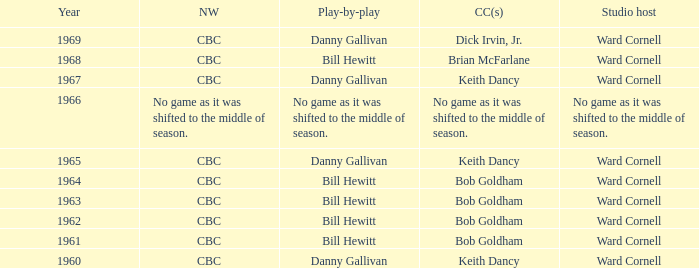Write the full table. {'header': ['Year', 'NW', 'Play-by-play', 'CC(s)', 'Studio host'], 'rows': [['1969', 'CBC', 'Danny Gallivan', 'Dick Irvin, Jr.', 'Ward Cornell'], ['1968', 'CBC', 'Bill Hewitt', 'Brian McFarlane', 'Ward Cornell'], ['1967', 'CBC', 'Danny Gallivan', 'Keith Dancy', 'Ward Cornell'], ['1966', 'No game as it was shifted to the middle of season.', 'No game as it was shifted to the middle of season.', 'No game as it was shifted to the middle of season.', 'No game as it was shifted to the middle of season.'], ['1965', 'CBC', 'Danny Gallivan', 'Keith Dancy', 'Ward Cornell'], ['1964', 'CBC', 'Bill Hewitt', 'Bob Goldham', 'Ward Cornell'], ['1963', 'CBC', 'Bill Hewitt', 'Bob Goldham', 'Ward Cornell'], ['1962', 'CBC', 'Bill Hewitt', 'Bob Goldham', 'Ward Cornell'], ['1961', 'CBC', 'Bill Hewitt', 'Bob Goldham', 'Ward Cornell'], ['1960', 'CBC', 'Danny Gallivan', 'Keith Dancy', 'Ward Cornell']]} Who did the play-by-play with studio host Ward Cornell and color commentator Bob Goldham? Bill Hewitt, Bill Hewitt, Bill Hewitt, Bill Hewitt. 